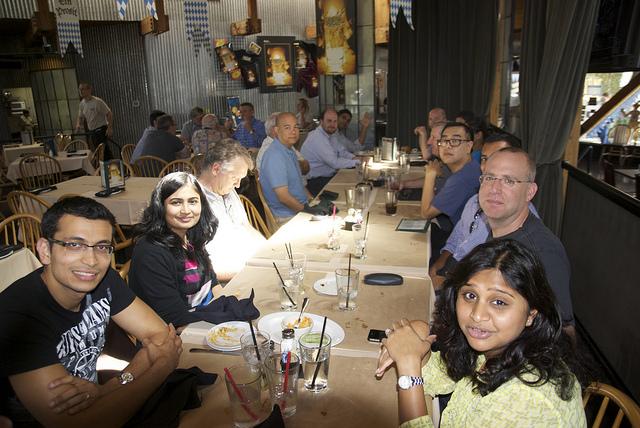What color is the lady in right foreground's clothing?
Write a very short answer. Yellow. Is this a formal or casual occasion?
Concise answer only. Casual. What type of glasses are on the table?
Answer briefly. Water glasses. What are these people probably drinking?
Write a very short answer. Water. What is the girl in the background wearing?
Write a very short answer. Dress. Are the people waiting for their food?
Give a very brief answer. Yes. Are they all the same race?
Quick response, please. No. Where are the people looking at?
Short answer required. Camera. What does the woman in the forefront have on her head?
Quick response, please. Hair. Are there wine bottles on the table?
Quick response, please. No. 